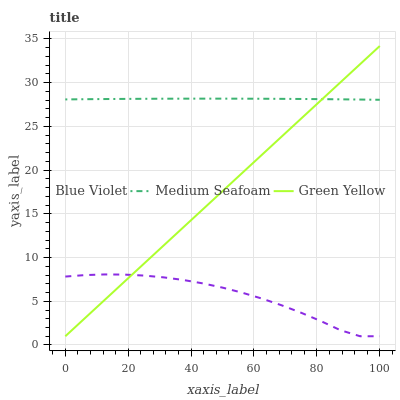Does Blue Violet have the minimum area under the curve?
Answer yes or no. Yes. Does Medium Seafoam have the maximum area under the curve?
Answer yes or no. Yes. Does Medium Seafoam have the minimum area under the curve?
Answer yes or no. No. Does Blue Violet have the maximum area under the curve?
Answer yes or no. No. Is Green Yellow the smoothest?
Answer yes or no. Yes. Is Blue Violet the roughest?
Answer yes or no. Yes. Is Medium Seafoam the smoothest?
Answer yes or no. No. Is Medium Seafoam the roughest?
Answer yes or no. No. Does Medium Seafoam have the lowest value?
Answer yes or no. No. Does Green Yellow have the highest value?
Answer yes or no. Yes. Does Medium Seafoam have the highest value?
Answer yes or no. No. Is Blue Violet less than Medium Seafoam?
Answer yes or no. Yes. Is Medium Seafoam greater than Blue Violet?
Answer yes or no. Yes. Does Blue Violet intersect Medium Seafoam?
Answer yes or no. No. 